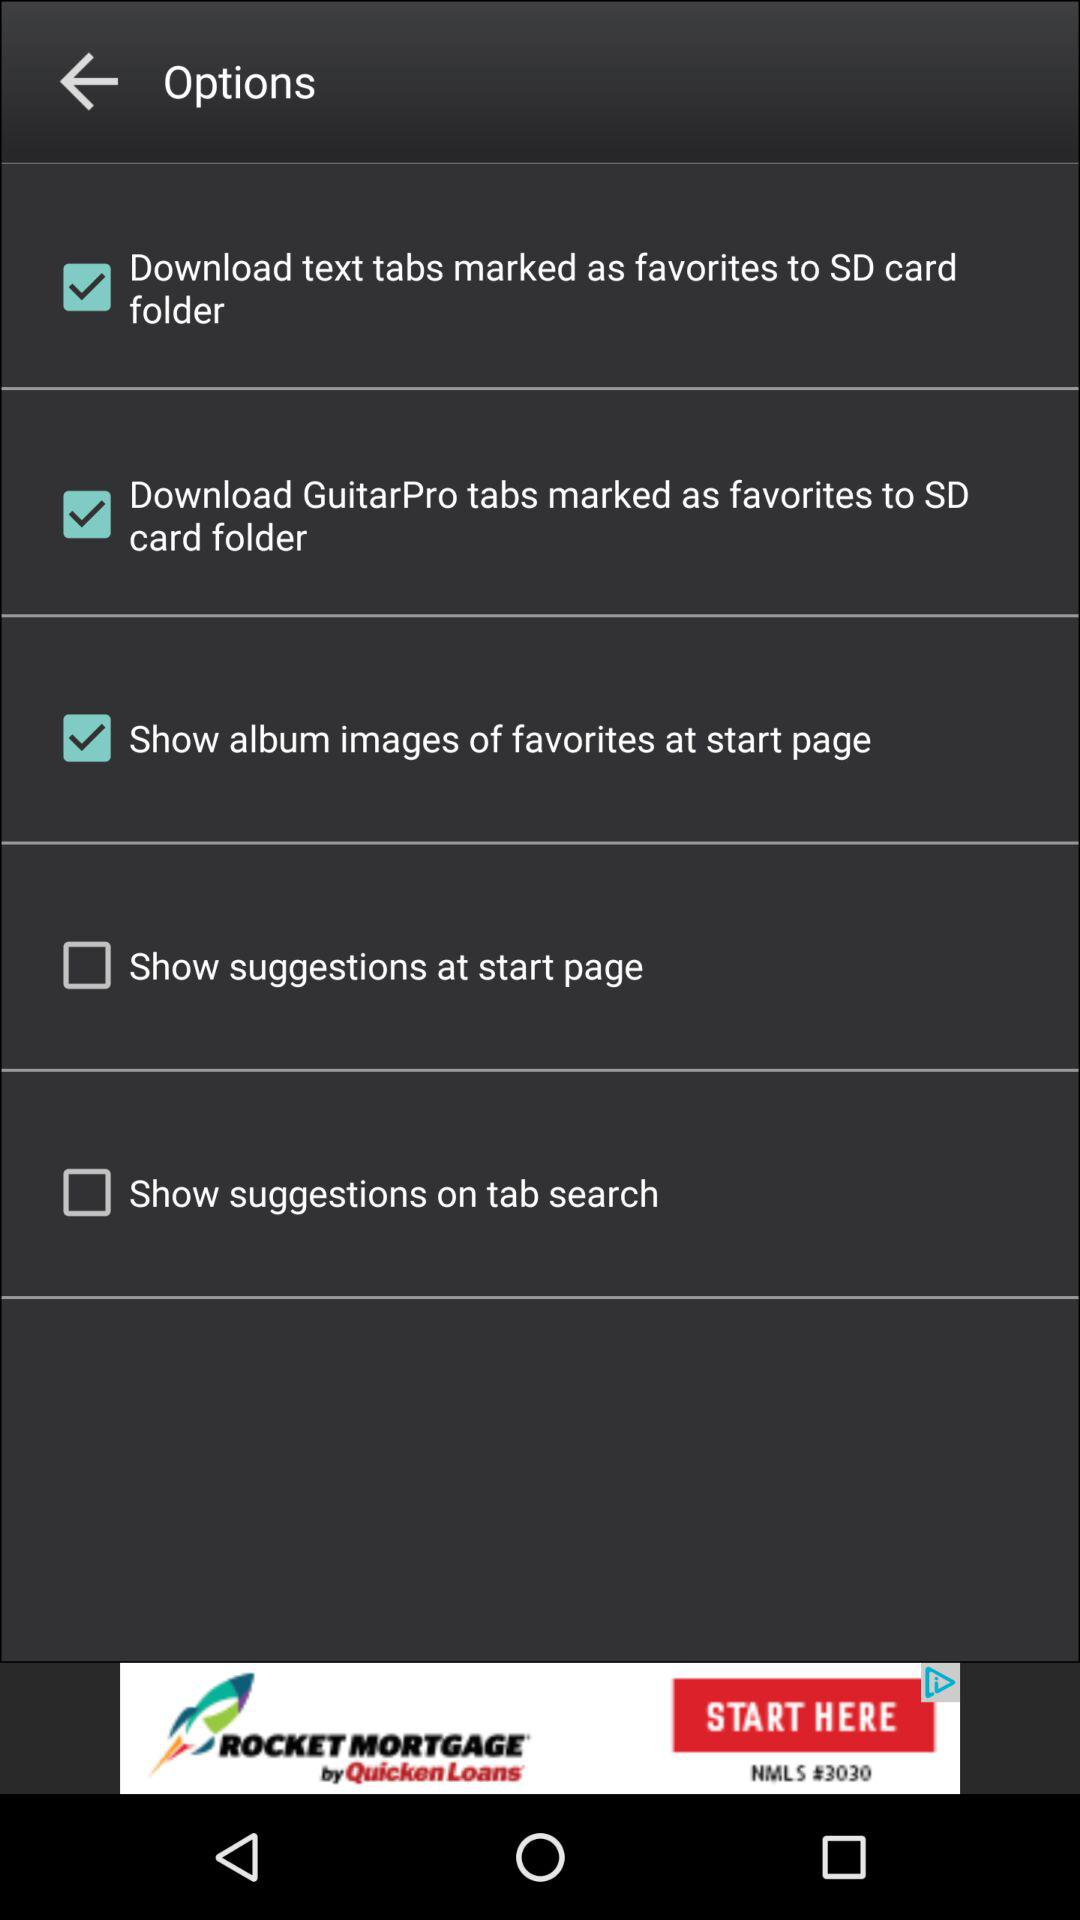What is the status of the "Show album images of favorites at start page"? The status of the "Show album images of favorites at start page" is "on". 